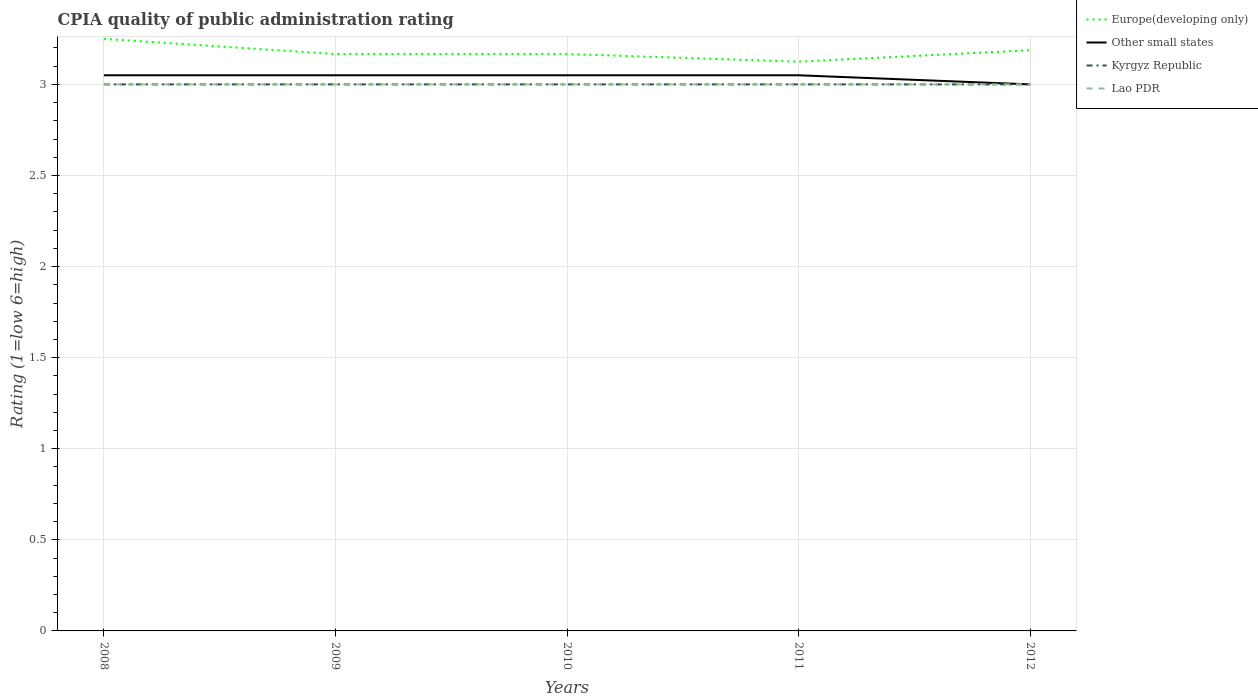Does the line corresponding to Lao PDR intersect with the line corresponding to Europe(developing only)?
Your response must be concise. No. Across all years, what is the maximum CPIA rating in Kyrgyz Republic?
Provide a succinct answer. 3. In which year was the CPIA rating in Europe(developing only) maximum?
Ensure brevity in your answer.  2011. What is the total CPIA rating in Europe(developing only) in the graph?
Make the answer very short. 0.06. What is the difference between the highest and the second highest CPIA rating in Other small states?
Offer a terse response. 0.05. What is the difference between the highest and the lowest CPIA rating in Europe(developing only)?
Your answer should be compact. 2. Is the CPIA rating in Other small states strictly greater than the CPIA rating in Kyrgyz Republic over the years?
Your answer should be compact. No. What is the difference between two consecutive major ticks on the Y-axis?
Give a very brief answer. 0.5. Are the values on the major ticks of Y-axis written in scientific E-notation?
Offer a very short reply. No. Does the graph contain any zero values?
Your answer should be compact. No. Where does the legend appear in the graph?
Provide a short and direct response. Top right. How many legend labels are there?
Make the answer very short. 4. How are the legend labels stacked?
Provide a short and direct response. Vertical. What is the title of the graph?
Keep it short and to the point. CPIA quality of public administration rating. Does "Central Europe" appear as one of the legend labels in the graph?
Ensure brevity in your answer.  No. What is the label or title of the X-axis?
Offer a very short reply. Years. What is the label or title of the Y-axis?
Keep it short and to the point. Rating (1=low 6=high). What is the Rating (1=low 6=high) in Other small states in 2008?
Ensure brevity in your answer.  3.05. What is the Rating (1=low 6=high) in Lao PDR in 2008?
Ensure brevity in your answer.  3. What is the Rating (1=low 6=high) in Europe(developing only) in 2009?
Offer a very short reply. 3.17. What is the Rating (1=low 6=high) in Other small states in 2009?
Offer a very short reply. 3.05. What is the Rating (1=low 6=high) in Europe(developing only) in 2010?
Your answer should be very brief. 3.17. What is the Rating (1=low 6=high) of Other small states in 2010?
Ensure brevity in your answer.  3.05. What is the Rating (1=low 6=high) in Lao PDR in 2010?
Make the answer very short. 3. What is the Rating (1=low 6=high) of Europe(developing only) in 2011?
Provide a short and direct response. 3.12. What is the Rating (1=low 6=high) of Other small states in 2011?
Make the answer very short. 3.05. What is the Rating (1=low 6=high) of Kyrgyz Republic in 2011?
Make the answer very short. 3. What is the Rating (1=low 6=high) of Lao PDR in 2011?
Your answer should be compact. 3. What is the Rating (1=low 6=high) of Europe(developing only) in 2012?
Offer a terse response. 3.19. What is the Rating (1=low 6=high) in Other small states in 2012?
Make the answer very short. 3. What is the Rating (1=low 6=high) in Kyrgyz Republic in 2012?
Provide a succinct answer. 3. Across all years, what is the maximum Rating (1=low 6=high) of Europe(developing only)?
Offer a very short reply. 3.25. Across all years, what is the maximum Rating (1=low 6=high) of Other small states?
Ensure brevity in your answer.  3.05. Across all years, what is the maximum Rating (1=low 6=high) of Lao PDR?
Provide a short and direct response. 3. Across all years, what is the minimum Rating (1=low 6=high) in Europe(developing only)?
Make the answer very short. 3.12. Across all years, what is the minimum Rating (1=low 6=high) of Other small states?
Keep it short and to the point. 3. Across all years, what is the minimum Rating (1=low 6=high) in Kyrgyz Republic?
Make the answer very short. 3. What is the total Rating (1=low 6=high) in Europe(developing only) in the graph?
Make the answer very short. 15.9. What is the total Rating (1=low 6=high) in Other small states in the graph?
Provide a short and direct response. 15.2. What is the total Rating (1=low 6=high) in Kyrgyz Republic in the graph?
Give a very brief answer. 15. What is the total Rating (1=low 6=high) in Lao PDR in the graph?
Give a very brief answer. 15. What is the difference between the Rating (1=low 6=high) in Europe(developing only) in 2008 and that in 2009?
Make the answer very short. 0.08. What is the difference between the Rating (1=low 6=high) in Kyrgyz Republic in 2008 and that in 2009?
Ensure brevity in your answer.  0. What is the difference between the Rating (1=low 6=high) in Lao PDR in 2008 and that in 2009?
Provide a succinct answer. 0. What is the difference between the Rating (1=low 6=high) in Europe(developing only) in 2008 and that in 2010?
Your answer should be very brief. 0.08. What is the difference between the Rating (1=low 6=high) in Other small states in 2008 and that in 2010?
Offer a very short reply. 0. What is the difference between the Rating (1=low 6=high) of Lao PDR in 2008 and that in 2010?
Your response must be concise. 0. What is the difference between the Rating (1=low 6=high) of Europe(developing only) in 2008 and that in 2011?
Give a very brief answer. 0.12. What is the difference between the Rating (1=low 6=high) of Other small states in 2008 and that in 2011?
Provide a short and direct response. 0. What is the difference between the Rating (1=low 6=high) in Kyrgyz Republic in 2008 and that in 2011?
Your response must be concise. 0. What is the difference between the Rating (1=low 6=high) of Europe(developing only) in 2008 and that in 2012?
Give a very brief answer. 0.06. What is the difference between the Rating (1=low 6=high) of Europe(developing only) in 2009 and that in 2010?
Offer a very short reply. 0. What is the difference between the Rating (1=low 6=high) in Kyrgyz Republic in 2009 and that in 2010?
Make the answer very short. 0. What is the difference between the Rating (1=low 6=high) in Europe(developing only) in 2009 and that in 2011?
Your answer should be compact. 0.04. What is the difference between the Rating (1=low 6=high) in Kyrgyz Republic in 2009 and that in 2011?
Your answer should be very brief. 0. What is the difference between the Rating (1=low 6=high) of Lao PDR in 2009 and that in 2011?
Your answer should be compact. 0. What is the difference between the Rating (1=low 6=high) in Europe(developing only) in 2009 and that in 2012?
Ensure brevity in your answer.  -0.02. What is the difference between the Rating (1=low 6=high) in Kyrgyz Republic in 2009 and that in 2012?
Give a very brief answer. 0. What is the difference between the Rating (1=low 6=high) in Lao PDR in 2009 and that in 2012?
Your response must be concise. 0. What is the difference between the Rating (1=low 6=high) in Europe(developing only) in 2010 and that in 2011?
Offer a terse response. 0.04. What is the difference between the Rating (1=low 6=high) of Other small states in 2010 and that in 2011?
Make the answer very short. 0. What is the difference between the Rating (1=low 6=high) of Europe(developing only) in 2010 and that in 2012?
Keep it short and to the point. -0.02. What is the difference between the Rating (1=low 6=high) in Europe(developing only) in 2011 and that in 2012?
Offer a very short reply. -0.06. What is the difference between the Rating (1=low 6=high) in Other small states in 2011 and that in 2012?
Your answer should be compact. 0.05. What is the difference between the Rating (1=low 6=high) in Kyrgyz Republic in 2011 and that in 2012?
Keep it short and to the point. 0. What is the difference between the Rating (1=low 6=high) in Lao PDR in 2011 and that in 2012?
Provide a short and direct response. 0. What is the difference between the Rating (1=low 6=high) in Europe(developing only) in 2008 and the Rating (1=low 6=high) in Other small states in 2009?
Ensure brevity in your answer.  0.2. What is the difference between the Rating (1=low 6=high) of Europe(developing only) in 2008 and the Rating (1=low 6=high) of Kyrgyz Republic in 2009?
Keep it short and to the point. 0.25. What is the difference between the Rating (1=low 6=high) in Europe(developing only) in 2008 and the Rating (1=low 6=high) in Lao PDR in 2009?
Offer a very short reply. 0.25. What is the difference between the Rating (1=low 6=high) in Other small states in 2008 and the Rating (1=low 6=high) in Kyrgyz Republic in 2009?
Provide a short and direct response. 0.05. What is the difference between the Rating (1=low 6=high) of Other small states in 2008 and the Rating (1=low 6=high) of Lao PDR in 2009?
Give a very brief answer. 0.05. What is the difference between the Rating (1=low 6=high) of Europe(developing only) in 2008 and the Rating (1=low 6=high) of Other small states in 2010?
Make the answer very short. 0.2. What is the difference between the Rating (1=low 6=high) of Other small states in 2008 and the Rating (1=low 6=high) of Kyrgyz Republic in 2010?
Provide a short and direct response. 0.05. What is the difference between the Rating (1=low 6=high) of Other small states in 2008 and the Rating (1=low 6=high) of Lao PDR in 2010?
Provide a succinct answer. 0.05. What is the difference between the Rating (1=low 6=high) of Kyrgyz Republic in 2008 and the Rating (1=low 6=high) of Lao PDR in 2010?
Your answer should be very brief. 0. What is the difference between the Rating (1=low 6=high) in Europe(developing only) in 2008 and the Rating (1=low 6=high) in Other small states in 2011?
Provide a succinct answer. 0.2. What is the difference between the Rating (1=low 6=high) in Europe(developing only) in 2008 and the Rating (1=low 6=high) in Lao PDR in 2011?
Offer a very short reply. 0.25. What is the difference between the Rating (1=low 6=high) of Europe(developing only) in 2008 and the Rating (1=low 6=high) of Other small states in 2012?
Offer a very short reply. 0.25. What is the difference between the Rating (1=low 6=high) in Europe(developing only) in 2008 and the Rating (1=low 6=high) in Kyrgyz Republic in 2012?
Make the answer very short. 0.25. What is the difference between the Rating (1=low 6=high) of Europe(developing only) in 2008 and the Rating (1=low 6=high) of Lao PDR in 2012?
Offer a terse response. 0.25. What is the difference between the Rating (1=low 6=high) in Other small states in 2008 and the Rating (1=low 6=high) in Lao PDR in 2012?
Your answer should be compact. 0.05. What is the difference between the Rating (1=low 6=high) of Europe(developing only) in 2009 and the Rating (1=low 6=high) of Other small states in 2010?
Ensure brevity in your answer.  0.12. What is the difference between the Rating (1=low 6=high) of Europe(developing only) in 2009 and the Rating (1=low 6=high) of Kyrgyz Republic in 2010?
Your response must be concise. 0.17. What is the difference between the Rating (1=low 6=high) in Europe(developing only) in 2009 and the Rating (1=low 6=high) in Lao PDR in 2010?
Offer a terse response. 0.17. What is the difference between the Rating (1=low 6=high) of Other small states in 2009 and the Rating (1=low 6=high) of Kyrgyz Republic in 2010?
Provide a short and direct response. 0.05. What is the difference between the Rating (1=low 6=high) of Other small states in 2009 and the Rating (1=low 6=high) of Lao PDR in 2010?
Make the answer very short. 0.05. What is the difference between the Rating (1=low 6=high) in Kyrgyz Republic in 2009 and the Rating (1=low 6=high) in Lao PDR in 2010?
Keep it short and to the point. 0. What is the difference between the Rating (1=low 6=high) of Europe(developing only) in 2009 and the Rating (1=low 6=high) of Other small states in 2011?
Offer a very short reply. 0.12. What is the difference between the Rating (1=low 6=high) of Europe(developing only) in 2009 and the Rating (1=low 6=high) of Kyrgyz Republic in 2011?
Ensure brevity in your answer.  0.17. What is the difference between the Rating (1=low 6=high) in Europe(developing only) in 2009 and the Rating (1=low 6=high) in Lao PDR in 2011?
Your answer should be very brief. 0.17. What is the difference between the Rating (1=low 6=high) of Other small states in 2009 and the Rating (1=low 6=high) of Kyrgyz Republic in 2011?
Provide a short and direct response. 0.05. What is the difference between the Rating (1=low 6=high) in Kyrgyz Republic in 2009 and the Rating (1=low 6=high) in Lao PDR in 2011?
Your answer should be compact. 0. What is the difference between the Rating (1=low 6=high) of Europe(developing only) in 2009 and the Rating (1=low 6=high) of Kyrgyz Republic in 2012?
Provide a short and direct response. 0.17. What is the difference between the Rating (1=low 6=high) of Other small states in 2009 and the Rating (1=low 6=high) of Kyrgyz Republic in 2012?
Provide a short and direct response. 0.05. What is the difference between the Rating (1=low 6=high) of Europe(developing only) in 2010 and the Rating (1=low 6=high) of Other small states in 2011?
Your answer should be compact. 0.12. What is the difference between the Rating (1=low 6=high) in Europe(developing only) in 2010 and the Rating (1=low 6=high) in Lao PDR in 2011?
Your response must be concise. 0.17. What is the difference between the Rating (1=low 6=high) in Other small states in 2010 and the Rating (1=low 6=high) in Kyrgyz Republic in 2011?
Your response must be concise. 0.05. What is the difference between the Rating (1=low 6=high) of Kyrgyz Republic in 2010 and the Rating (1=low 6=high) of Lao PDR in 2011?
Offer a terse response. 0. What is the difference between the Rating (1=low 6=high) of Kyrgyz Republic in 2010 and the Rating (1=low 6=high) of Lao PDR in 2012?
Ensure brevity in your answer.  0. What is the difference between the Rating (1=low 6=high) in Europe(developing only) in 2011 and the Rating (1=low 6=high) in Kyrgyz Republic in 2012?
Your answer should be compact. 0.12. What is the difference between the Rating (1=low 6=high) of Europe(developing only) in 2011 and the Rating (1=low 6=high) of Lao PDR in 2012?
Make the answer very short. 0.12. What is the difference between the Rating (1=low 6=high) in Kyrgyz Republic in 2011 and the Rating (1=low 6=high) in Lao PDR in 2012?
Offer a very short reply. 0. What is the average Rating (1=low 6=high) of Europe(developing only) per year?
Offer a terse response. 3.18. What is the average Rating (1=low 6=high) in Other small states per year?
Provide a succinct answer. 3.04. In the year 2008, what is the difference between the Rating (1=low 6=high) in Europe(developing only) and Rating (1=low 6=high) in Kyrgyz Republic?
Keep it short and to the point. 0.25. In the year 2008, what is the difference between the Rating (1=low 6=high) of Europe(developing only) and Rating (1=low 6=high) of Lao PDR?
Your response must be concise. 0.25. In the year 2009, what is the difference between the Rating (1=low 6=high) in Europe(developing only) and Rating (1=low 6=high) in Other small states?
Your answer should be compact. 0.12. In the year 2009, what is the difference between the Rating (1=low 6=high) in Europe(developing only) and Rating (1=low 6=high) in Kyrgyz Republic?
Your response must be concise. 0.17. In the year 2009, what is the difference between the Rating (1=low 6=high) in Other small states and Rating (1=low 6=high) in Kyrgyz Republic?
Make the answer very short. 0.05. In the year 2010, what is the difference between the Rating (1=low 6=high) in Europe(developing only) and Rating (1=low 6=high) in Other small states?
Make the answer very short. 0.12. In the year 2010, what is the difference between the Rating (1=low 6=high) of Europe(developing only) and Rating (1=low 6=high) of Kyrgyz Republic?
Your answer should be very brief. 0.17. In the year 2010, what is the difference between the Rating (1=low 6=high) in Other small states and Rating (1=low 6=high) in Kyrgyz Republic?
Your answer should be very brief. 0.05. In the year 2010, what is the difference between the Rating (1=low 6=high) of Other small states and Rating (1=low 6=high) of Lao PDR?
Make the answer very short. 0.05. In the year 2010, what is the difference between the Rating (1=low 6=high) of Kyrgyz Republic and Rating (1=low 6=high) of Lao PDR?
Offer a very short reply. 0. In the year 2011, what is the difference between the Rating (1=low 6=high) in Europe(developing only) and Rating (1=low 6=high) in Other small states?
Your response must be concise. 0.07. In the year 2011, what is the difference between the Rating (1=low 6=high) of Europe(developing only) and Rating (1=low 6=high) of Kyrgyz Republic?
Keep it short and to the point. 0.12. In the year 2011, what is the difference between the Rating (1=low 6=high) in Kyrgyz Republic and Rating (1=low 6=high) in Lao PDR?
Provide a succinct answer. 0. In the year 2012, what is the difference between the Rating (1=low 6=high) of Europe(developing only) and Rating (1=low 6=high) of Other small states?
Your response must be concise. 0.19. In the year 2012, what is the difference between the Rating (1=low 6=high) of Europe(developing only) and Rating (1=low 6=high) of Kyrgyz Republic?
Provide a succinct answer. 0.19. In the year 2012, what is the difference between the Rating (1=low 6=high) in Europe(developing only) and Rating (1=low 6=high) in Lao PDR?
Give a very brief answer. 0.19. In the year 2012, what is the difference between the Rating (1=low 6=high) in Kyrgyz Republic and Rating (1=low 6=high) in Lao PDR?
Your answer should be compact. 0. What is the ratio of the Rating (1=low 6=high) of Europe(developing only) in 2008 to that in 2009?
Offer a terse response. 1.03. What is the ratio of the Rating (1=low 6=high) in Lao PDR in 2008 to that in 2009?
Keep it short and to the point. 1. What is the ratio of the Rating (1=low 6=high) in Europe(developing only) in 2008 to that in 2010?
Make the answer very short. 1.03. What is the ratio of the Rating (1=low 6=high) in Other small states in 2008 to that in 2010?
Your answer should be compact. 1. What is the ratio of the Rating (1=low 6=high) in Kyrgyz Republic in 2008 to that in 2010?
Your response must be concise. 1. What is the ratio of the Rating (1=low 6=high) in Lao PDR in 2008 to that in 2010?
Your answer should be very brief. 1. What is the ratio of the Rating (1=low 6=high) in Europe(developing only) in 2008 to that in 2011?
Your answer should be very brief. 1.04. What is the ratio of the Rating (1=low 6=high) of Other small states in 2008 to that in 2011?
Offer a terse response. 1. What is the ratio of the Rating (1=low 6=high) in Lao PDR in 2008 to that in 2011?
Your answer should be very brief. 1. What is the ratio of the Rating (1=low 6=high) of Europe(developing only) in 2008 to that in 2012?
Provide a succinct answer. 1.02. What is the ratio of the Rating (1=low 6=high) in Other small states in 2008 to that in 2012?
Your answer should be very brief. 1.02. What is the ratio of the Rating (1=low 6=high) of Lao PDR in 2008 to that in 2012?
Your response must be concise. 1. What is the ratio of the Rating (1=low 6=high) of Other small states in 2009 to that in 2010?
Keep it short and to the point. 1. What is the ratio of the Rating (1=low 6=high) in Europe(developing only) in 2009 to that in 2011?
Your response must be concise. 1.01. What is the ratio of the Rating (1=low 6=high) in Kyrgyz Republic in 2009 to that in 2011?
Provide a succinct answer. 1. What is the ratio of the Rating (1=low 6=high) in Lao PDR in 2009 to that in 2011?
Give a very brief answer. 1. What is the ratio of the Rating (1=low 6=high) in Other small states in 2009 to that in 2012?
Keep it short and to the point. 1.02. What is the ratio of the Rating (1=low 6=high) in Kyrgyz Republic in 2009 to that in 2012?
Offer a very short reply. 1. What is the ratio of the Rating (1=low 6=high) of Lao PDR in 2009 to that in 2012?
Ensure brevity in your answer.  1. What is the ratio of the Rating (1=low 6=high) of Europe(developing only) in 2010 to that in 2011?
Give a very brief answer. 1.01. What is the ratio of the Rating (1=low 6=high) in Kyrgyz Republic in 2010 to that in 2011?
Your answer should be very brief. 1. What is the ratio of the Rating (1=low 6=high) in Other small states in 2010 to that in 2012?
Provide a succinct answer. 1.02. What is the ratio of the Rating (1=low 6=high) in Lao PDR in 2010 to that in 2012?
Keep it short and to the point. 1. What is the ratio of the Rating (1=low 6=high) of Europe(developing only) in 2011 to that in 2012?
Your answer should be very brief. 0.98. What is the ratio of the Rating (1=low 6=high) in Other small states in 2011 to that in 2012?
Offer a very short reply. 1.02. What is the ratio of the Rating (1=low 6=high) in Lao PDR in 2011 to that in 2012?
Your response must be concise. 1. What is the difference between the highest and the second highest Rating (1=low 6=high) of Europe(developing only)?
Give a very brief answer. 0.06. What is the difference between the highest and the second highest Rating (1=low 6=high) of Other small states?
Offer a very short reply. 0. What is the difference between the highest and the lowest Rating (1=low 6=high) of Europe(developing only)?
Provide a short and direct response. 0.12. 